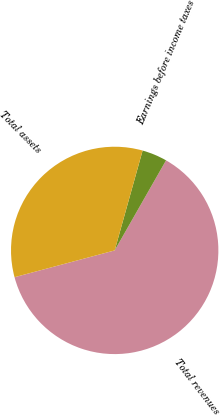Convert chart. <chart><loc_0><loc_0><loc_500><loc_500><pie_chart><fcel>Total revenues<fcel>Earnings before income taxes<fcel>Total assets<nl><fcel>62.59%<fcel>3.91%<fcel>33.5%<nl></chart> 